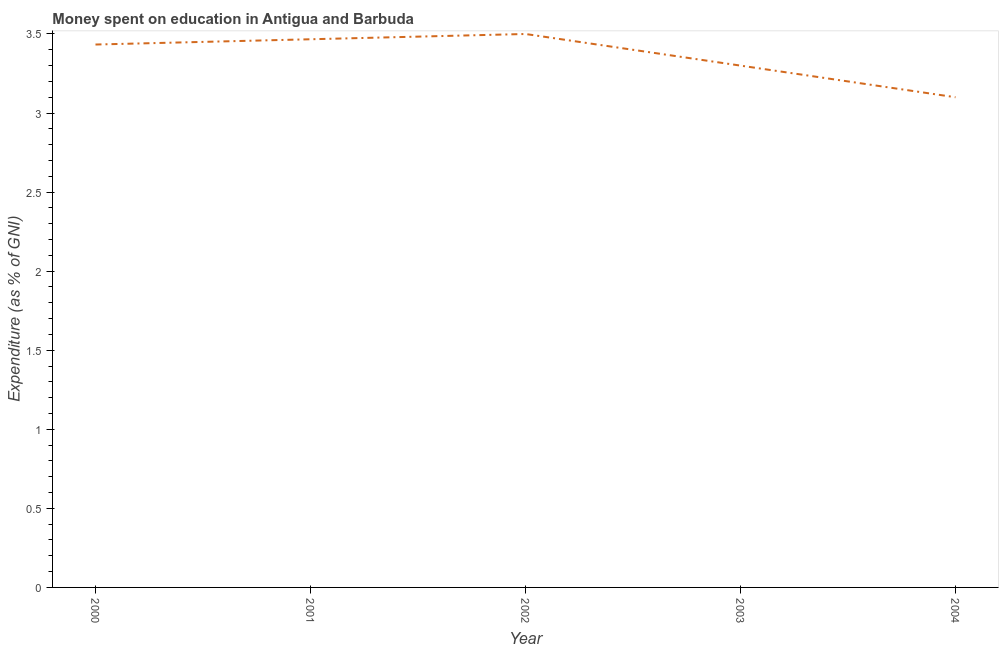What is the expenditure on education in 2002?
Keep it short and to the point. 3.5. Across all years, what is the minimum expenditure on education?
Keep it short and to the point. 3.1. What is the sum of the expenditure on education?
Your answer should be very brief. 16.8. What is the difference between the expenditure on education in 2000 and 2002?
Offer a very short reply. -0.07. What is the average expenditure on education per year?
Provide a succinct answer. 3.36. What is the median expenditure on education?
Offer a terse response. 3.43. In how many years, is the expenditure on education greater than 0.5 %?
Your answer should be compact. 5. What is the ratio of the expenditure on education in 2002 to that in 2003?
Your answer should be compact. 1.06. Is the expenditure on education in 2001 less than that in 2004?
Provide a short and direct response. No. What is the difference between the highest and the second highest expenditure on education?
Offer a terse response. 0.03. What is the difference between the highest and the lowest expenditure on education?
Provide a succinct answer. 0.4. In how many years, is the expenditure on education greater than the average expenditure on education taken over all years?
Provide a succinct answer. 3. Does the expenditure on education monotonically increase over the years?
Ensure brevity in your answer.  No. How many years are there in the graph?
Your answer should be compact. 5. Does the graph contain any zero values?
Ensure brevity in your answer.  No. Does the graph contain grids?
Make the answer very short. No. What is the title of the graph?
Make the answer very short. Money spent on education in Antigua and Barbuda. What is the label or title of the X-axis?
Make the answer very short. Year. What is the label or title of the Y-axis?
Provide a succinct answer. Expenditure (as % of GNI). What is the Expenditure (as % of GNI) in 2000?
Offer a terse response. 3.43. What is the Expenditure (as % of GNI) of 2001?
Give a very brief answer. 3.47. What is the Expenditure (as % of GNI) in 2002?
Give a very brief answer. 3.5. What is the Expenditure (as % of GNI) of 2003?
Your answer should be very brief. 3.3. What is the Expenditure (as % of GNI) of 2004?
Your response must be concise. 3.1. What is the difference between the Expenditure (as % of GNI) in 2000 and 2001?
Provide a short and direct response. -0.03. What is the difference between the Expenditure (as % of GNI) in 2000 and 2002?
Ensure brevity in your answer.  -0.07. What is the difference between the Expenditure (as % of GNI) in 2000 and 2003?
Make the answer very short. 0.13. What is the difference between the Expenditure (as % of GNI) in 2000 and 2004?
Offer a very short reply. 0.33. What is the difference between the Expenditure (as % of GNI) in 2001 and 2002?
Your answer should be compact. -0.03. What is the difference between the Expenditure (as % of GNI) in 2001 and 2003?
Your response must be concise. 0.17. What is the difference between the Expenditure (as % of GNI) in 2001 and 2004?
Make the answer very short. 0.37. What is the difference between the Expenditure (as % of GNI) in 2002 and 2003?
Give a very brief answer. 0.2. What is the difference between the Expenditure (as % of GNI) in 2002 and 2004?
Your answer should be very brief. 0.4. What is the ratio of the Expenditure (as % of GNI) in 2000 to that in 2001?
Your answer should be compact. 0.99. What is the ratio of the Expenditure (as % of GNI) in 2000 to that in 2002?
Your response must be concise. 0.98. What is the ratio of the Expenditure (as % of GNI) in 2000 to that in 2003?
Make the answer very short. 1.04. What is the ratio of the Expenditure (as % of GNI) in 2000 to that in 2004?
Provide a short and direct response. 1.11. What is the ratio of the Expenditure (as % of GNI) in 2001 to that in 2003?
Ensure brevity in your answer.  1.05. What is the ratio of the Expenditure (as % of GNI) in 2001 to that in 2004?
Make the answer very short. 1.12. What is the ratio of the Expenditure (as % of GNI) in 2002 to that in 2003?
Provide a succinct answer. 1.06. What is the ratio of the Expenditure (as % of GNI) in 2002 to that in 2004?
Your answer should be compact. 1.13. What is the ratio of the Expenditure (as % of GNI) in 2003 to that in 2004?
Make the answer very short. 1.06. 